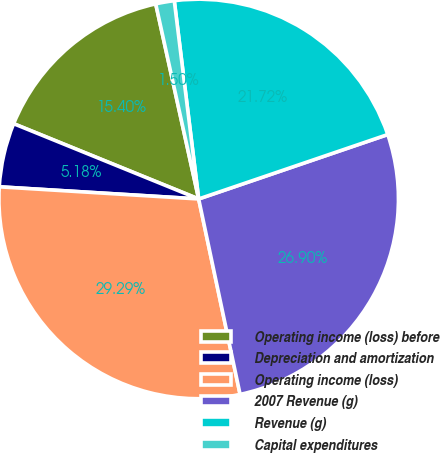Convert chart. <chart><loc_0><loc_0><loc_500><loc_500><pie_chart><fcel>Operating income (loss) before<fcel>Depreciation and amortization<fcel>Operating income (loss)<fcel>2007 Revenue (g)<fcel>Revenue (g)<fcel>Capital expenditures<nl><fcel>15.4%<fcel>5.18%<fcel>29.29%<fcel>26.9%<fcel>21.72%<fcel>1.5%<nl></chart> 